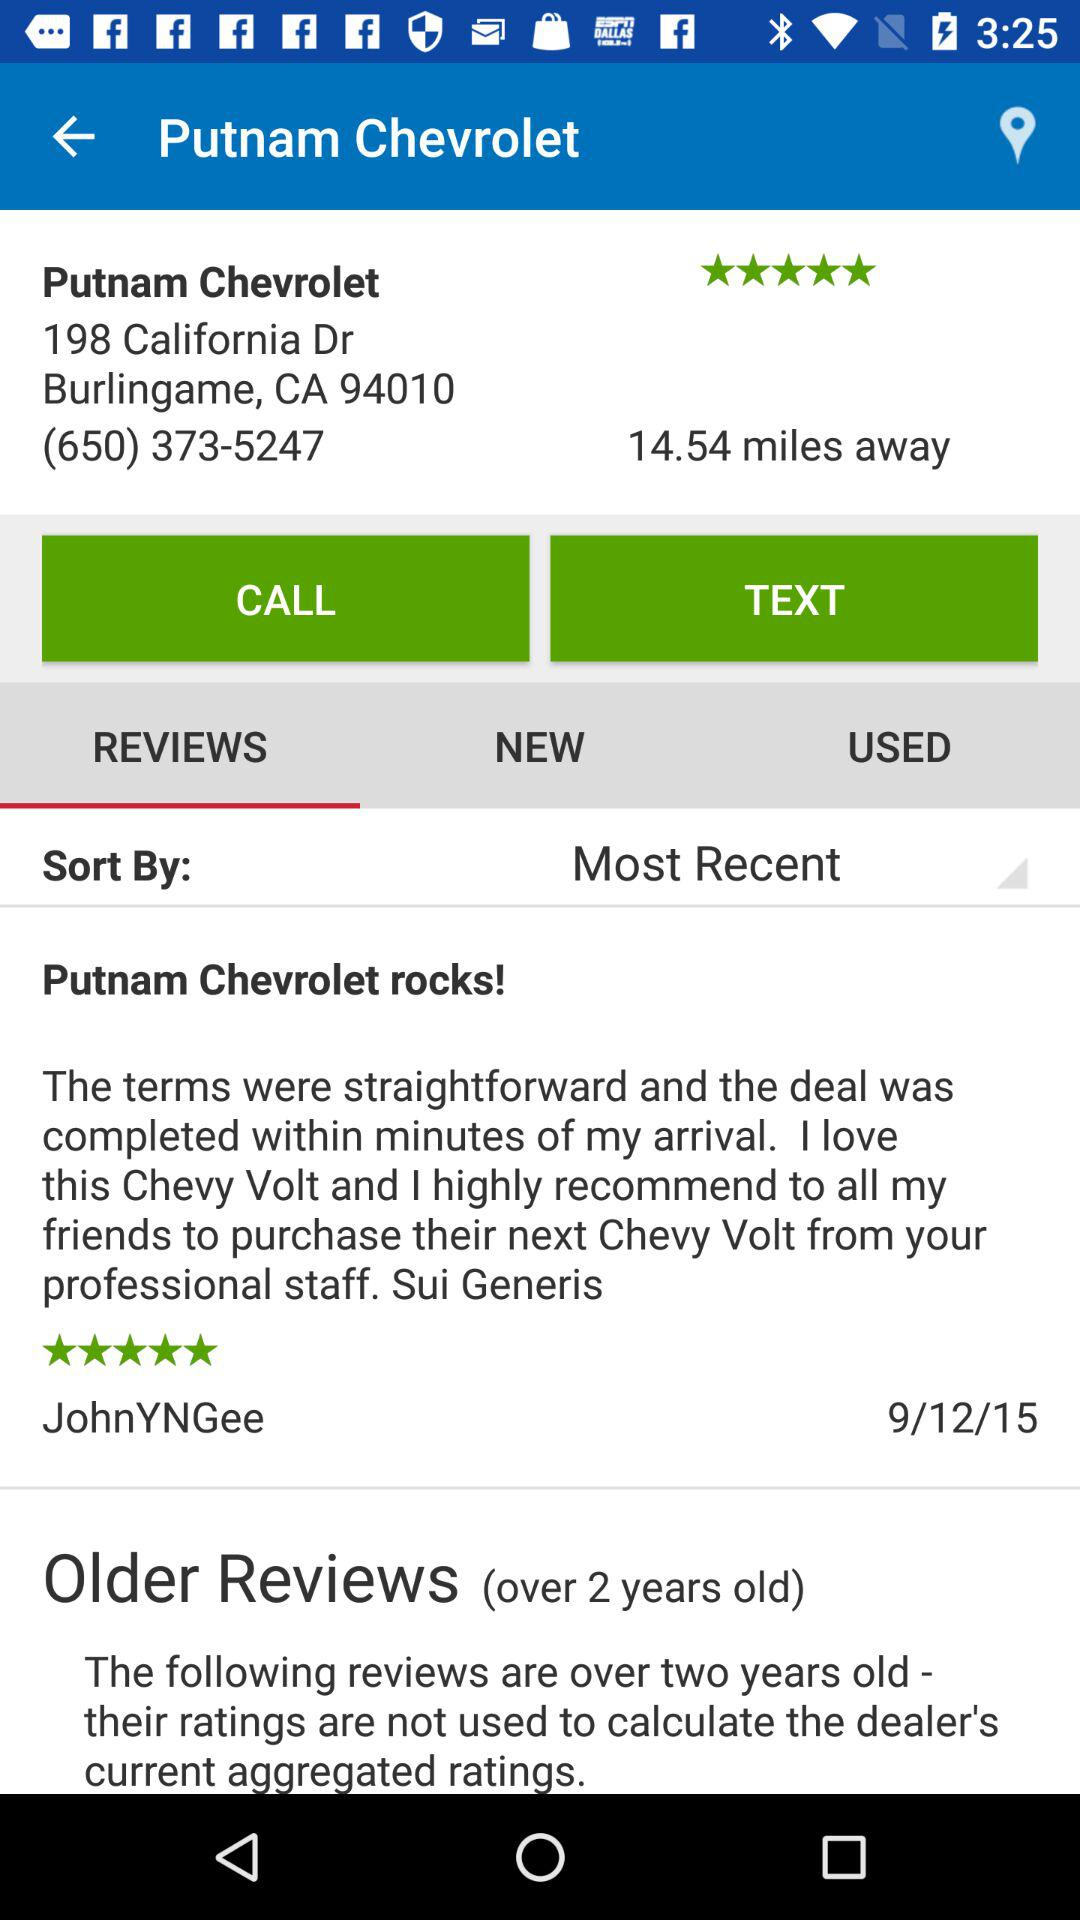What is the phone number? The phone number is (650) 373-5247. 